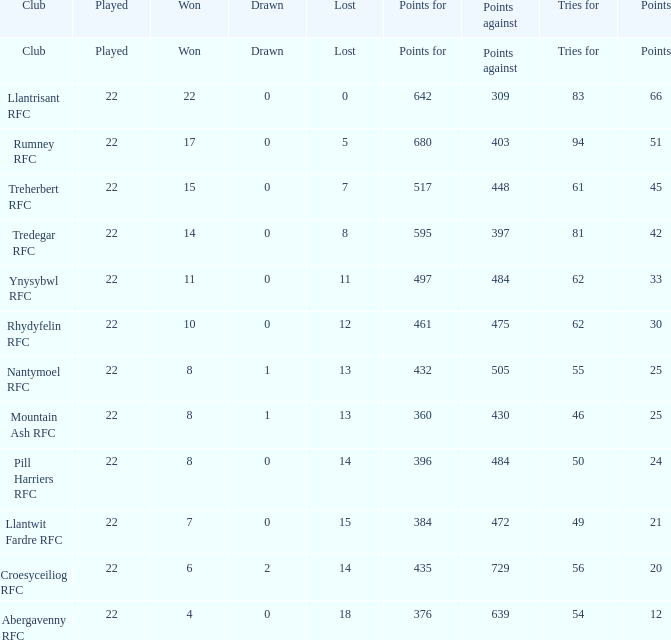How many matches were won by the teams that scored exactly 61 tries for? 15.0. 